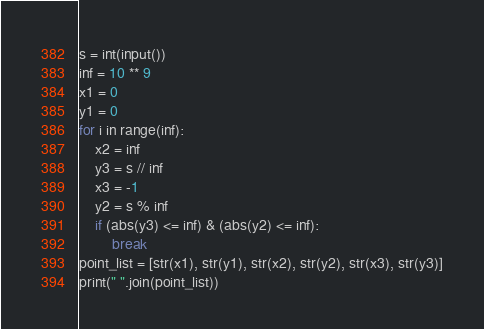Convert code to text. <code><loc_0><loc_0><loc_500><loc_500><_Python_>s = int(input())
inf = 10 ** 9
x1 = 0
y1 = 0
for i in range(inf):
    x2 = inf
    y3 = s // inf
    x3 = -1
    y2 = s % inf
    if (abs(y3) <= inf) & (abs(y2) <= inf):
        break
point_list = [str(x1), str(y1), str(x2), str(y2), str(x3), str(y3)]
print(" ".join(point_list))</code> 